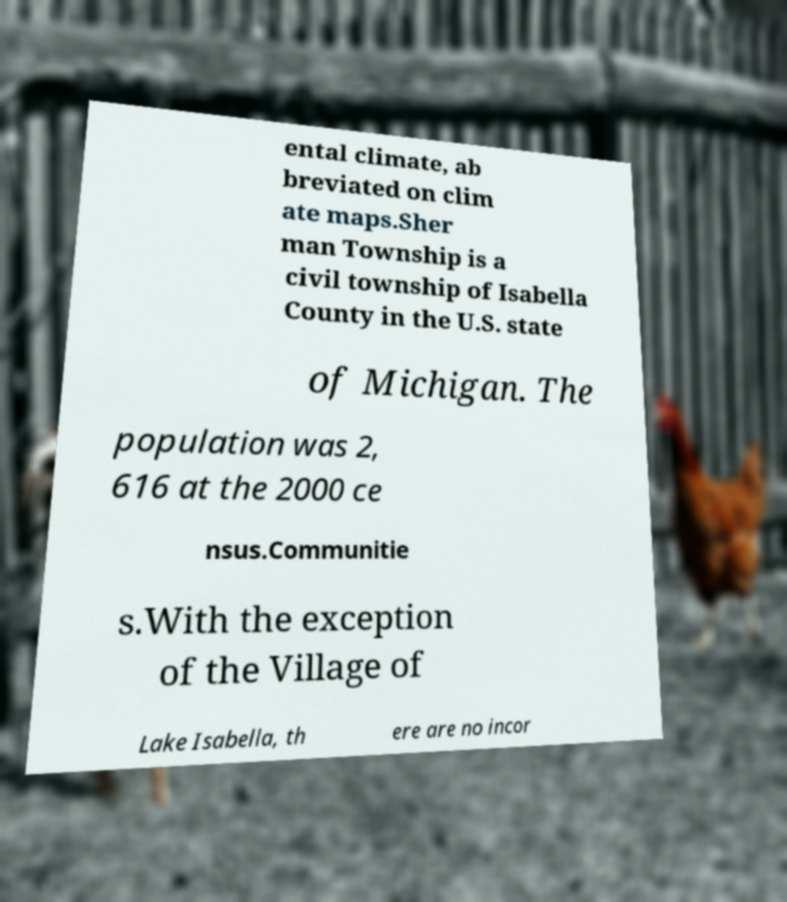Please identify and transcribe the text found in this image. ental climate, ab breviated on clim ate maps.Sher man Township is a civil township of Isabella County in the U.S. state of Michigan. The population was 2, 616 at the 2000 ce nsus.Communitie s.With the exception of the Village of Lake Isabella, th ere are no incor 